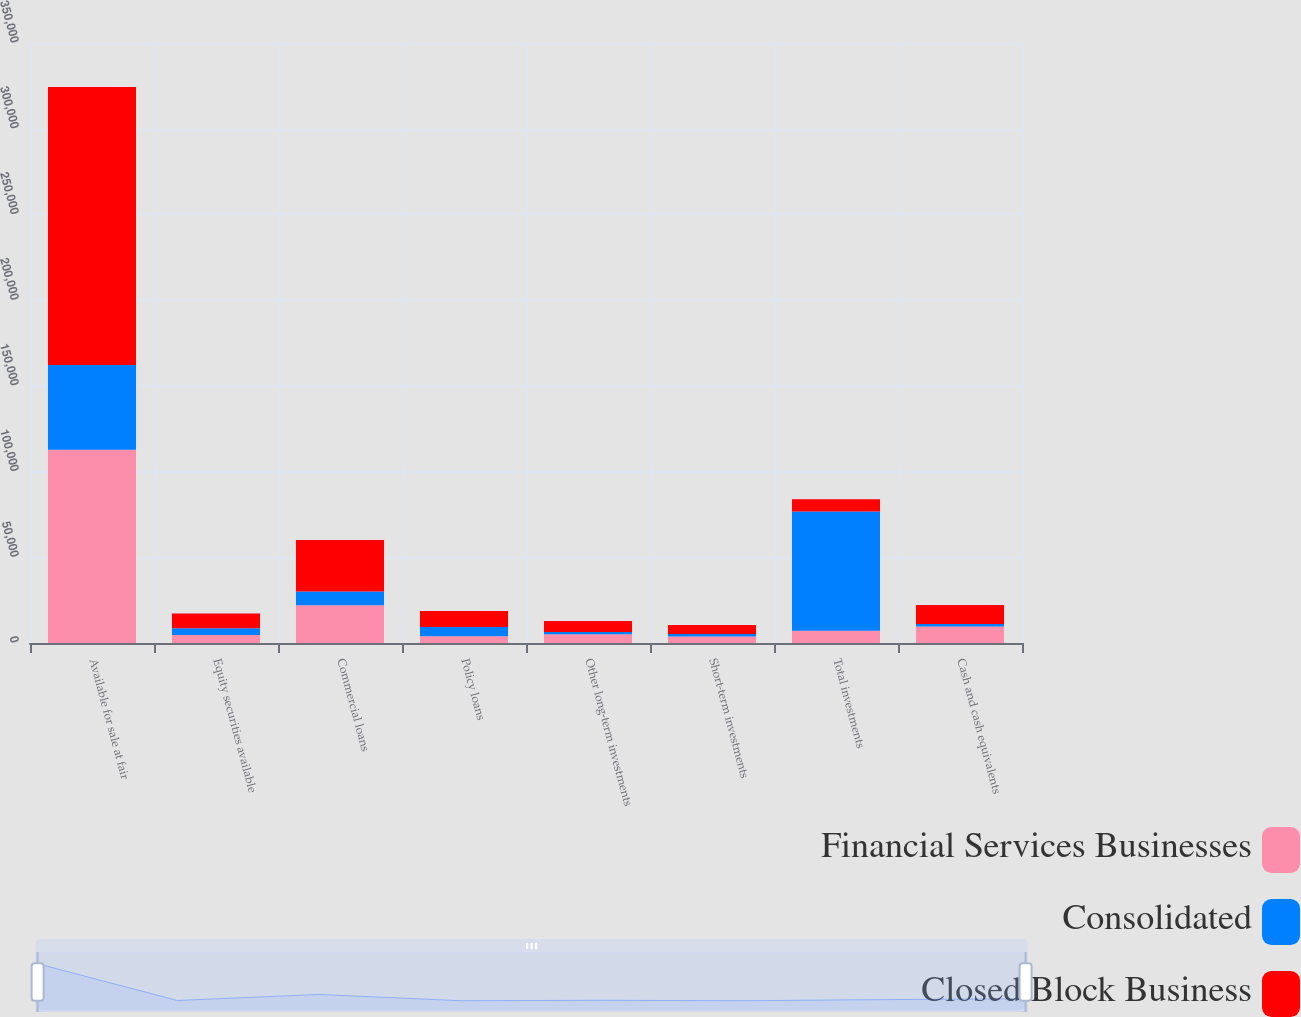<chart> <loc_0><loc_0><loc_500><loc_500><stacked_bar_chart><ecel><fcel>Available for sale at fair<fcel>Equity securities available<fcel>Commercial loans<fcel>Policy loans<fcel>Other long-term investments<fcel>Short-term investments<fcel>Total investments<fcel>Cash and cash equivalents<nl><fcel>Financial Services Businesses<fcel>112748<fcel>4640<fcel>22093<fcel>3942<fcel>5163<fcel>3852<fcel>7192.5<fcel>9624<nl><fcel>Consolidated<fcel>49414<fcel>3940<fcel>7954<fcel>5395<fcel>1268<fcel>1385<fcel>69498<fcel>1436<nl><fcel>Closed Block Business<fcel>162162<fcel>8580<fcel>30047<fcel>9337<fcel>6431<fcel>5237<fcel>7192.5<fcel>11060<nl></chart> 